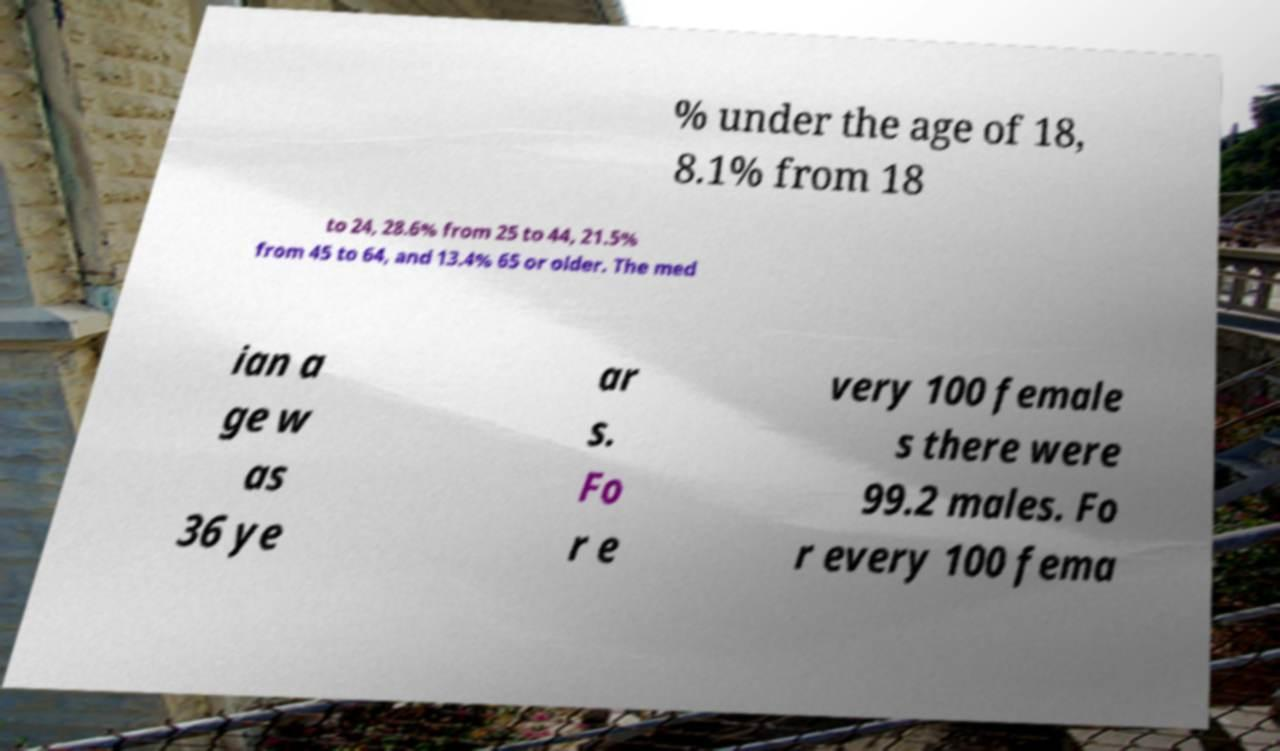Please read and relay the text visible in this image. What does it say? % under the age of 18, 8.1% from 18 to 24, 28.6% from 25 to 44, 21.5% from 45 to 64, and 13.4% 65 or older. The med ian a ge w as 36 ye ar s. Fo r e very 100 female s there were 99.2 males. Fo r every 100 fema 